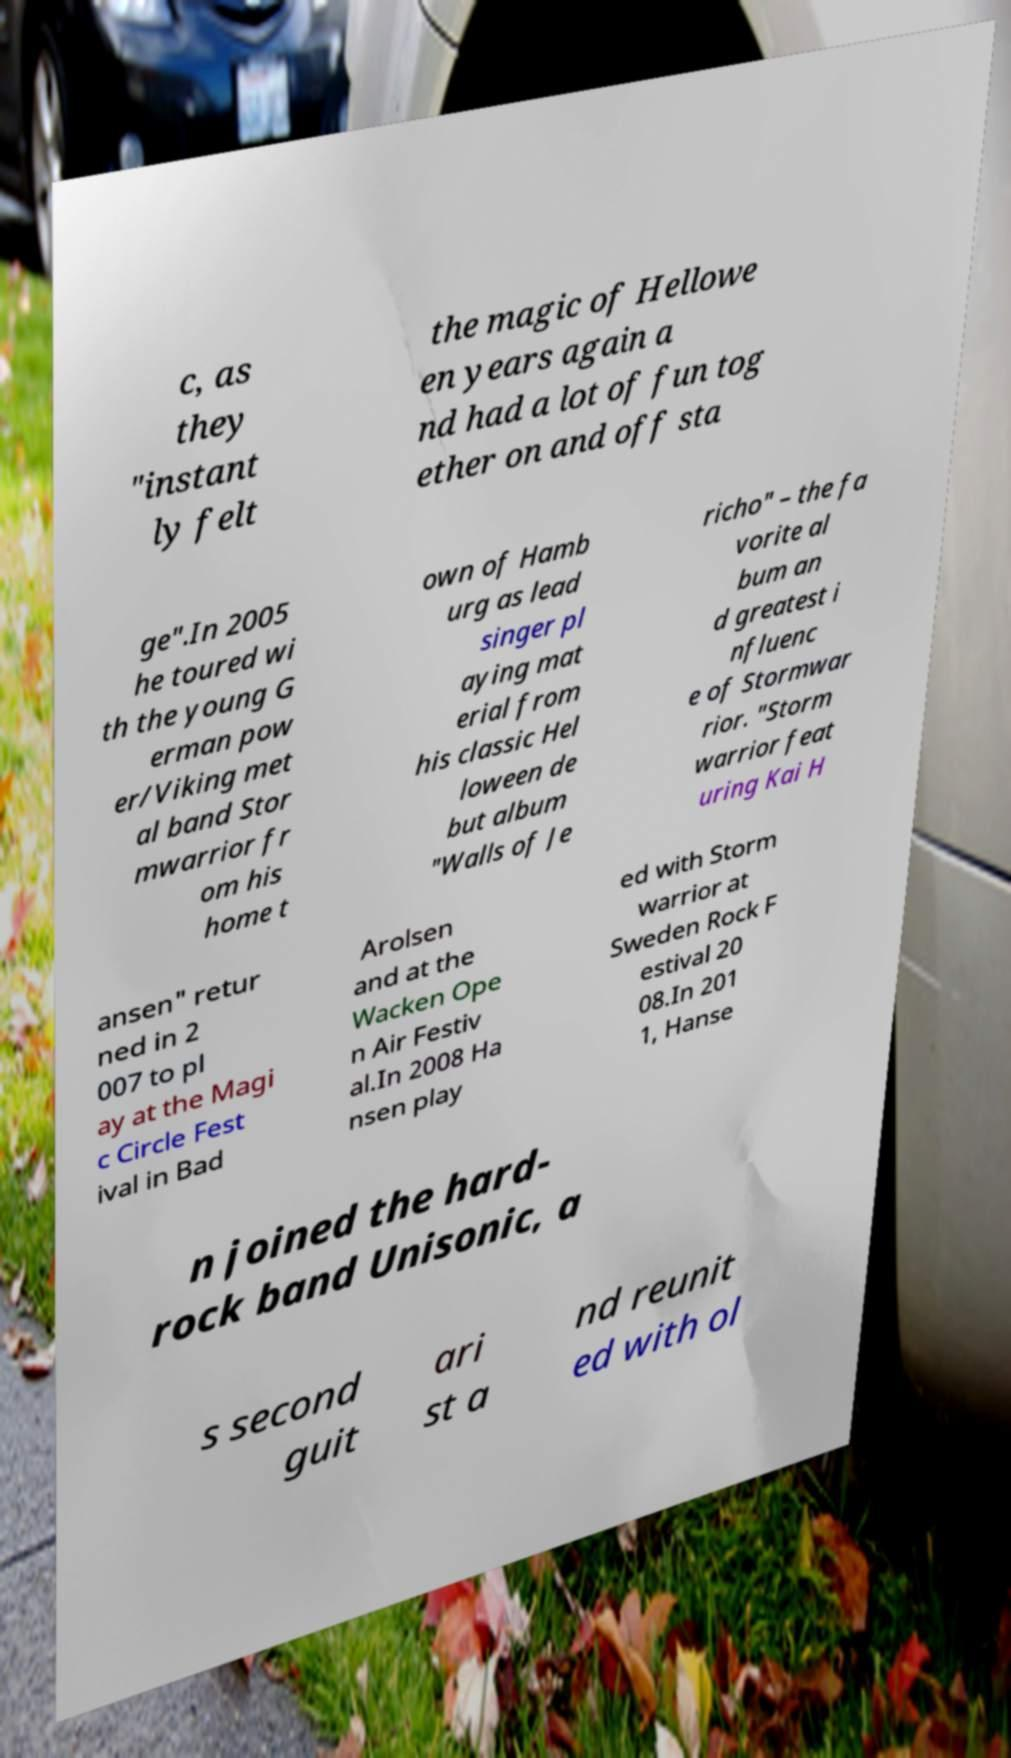For documentation purposes, I need the text within this image transcribed. Could you provide that? c, as they "instant ly felt the magic of Hellowe en years again a nd had a lot of fun tog ether on and off sta ge".In 2005 he toured wi th the young G erman pow er/Viking met al band Stor mwarrior fr om his home t own of Hamb urg as lead singer pl aying mat erial from his classic Hel loween de but album "Walls of Je richo" – the fa vorite al bum an d greatest i nfluenc e of Stormwar rior. "Storm warrior feat uring Kai H ansen" retur ned in 2 007 to pl ay at the Magi c Circle Fest ival in Bad Arolsen and at the Wacken Ope n Air Festiv al.In 2008 Ha nsen play ed with Storm warrior at Sweden Rock F estival 20 08.In 201 1, Hanse n joined the hard- rock band Unisonic, a s second guit ari st a nd reunit ed with ol 